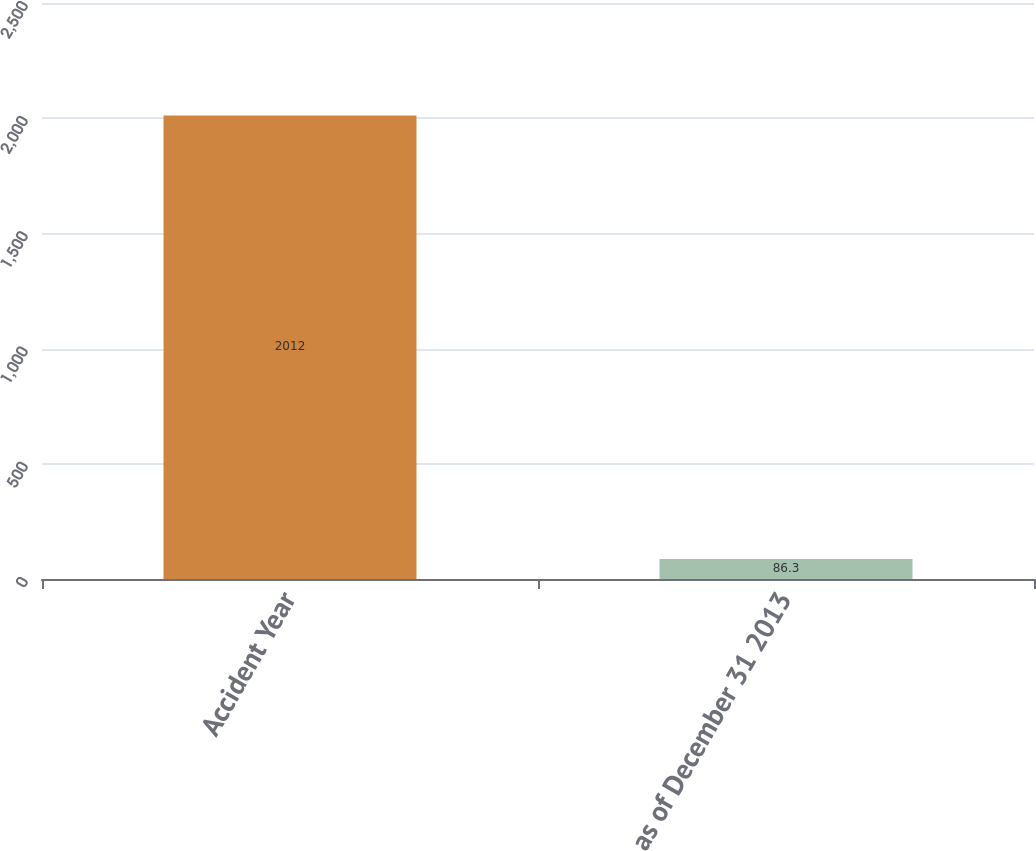<chart> <loc_0><loc_0><loc_500><loc_500><bar_chart><fcel>Accident Year<fcel>as of December 31 2013<nl><fcel>2012<fcel>86.3<nl></chart> 